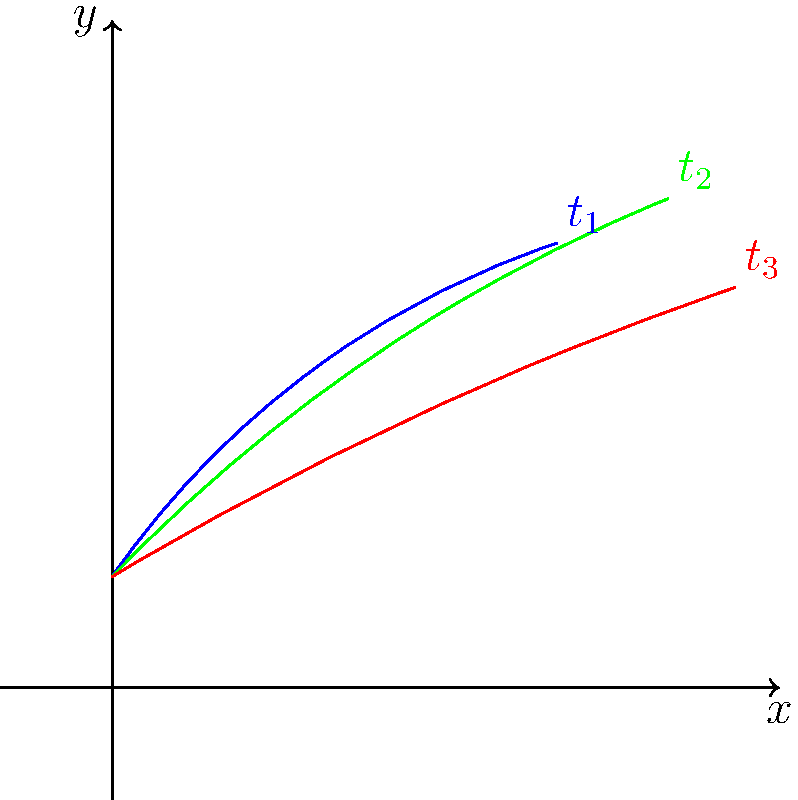Given the arm positions of a baseball pitcher at three different time points ($t_1$, $t_2$, and $t_3$) during a pitch, as shown in the figure, how would you calculate the average angular velocity of the arm between $t_1$ and $t_3$? Assume the time interval between each position is 0.1 seconds. To calculate the average angular velocity of the arm between $t_1$ and $t_3$, we need to follow these steps:

1. Determine the angular displacement:
   - Estimate the angle of the arm at $t_1$ and $t_3$ relative to a fixed reference (e.g., horizontal axis).
   - Calculate the difference between these angles.

2. Calculate the time interval:
   - Given: Time interval between each position is 0.1 seconds.
   - Total time from $t_1$ to $t_3$ = 2 * 0.1 = 0.2 seconds.

3. Apply the formula for average angular velocity:
   $$ \omega_{avg} = \frac{\Delta \theta}{\Delta t} $$
   Where:
   $\omega_{avg}$ is the average angular velocity
   $\Delta \theta$ is the angular displacement
   $\Delta t$ is the time interval

4. Estimate angles (approximate values):
   - At $t_1$: $\theta_1 \approx 60°$
   - At $t_3$: $\theta_3 \approx 20°$
   
   Angular displacement: $\Delta \theta = 60° - 20° = 40° = \frac{\pi}{4.5}$ radians

5. Calculate average angular velocity:
   $$ \omega_{avg} = \frac{\frac{\pi}{4.5}}{0.2} = \frac{5\pi}{9} \approx 1.75 \text{ rad/s} $$

Note: The actual angles may vary based on precise measurements from the diagram. This calculation provides an approximation of the average angular velocity.
Answer: $\frac{5\pi}{9}$ rad/s 